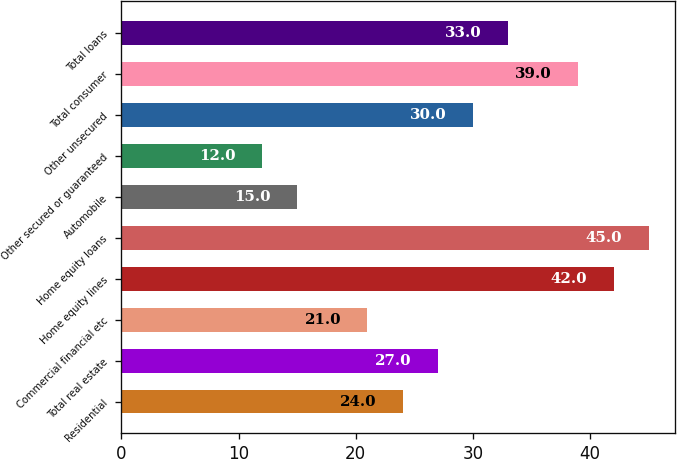Convert chart to OTSL. <chart><loc_0><loc_0><loc_500><loc_500><bar_chart><fcel>Residential<fcel>Total real estate<fcel>Commercial financial etc<fcel>Home equity lines<fcel>Home equity loans<fcel>Automobile<fcel>Other secured or guaranteed<fcel>Other unsecured<fcel>Total consumer<fcel>Total loans<nl><fcel>24<fcel>27<fcel>21<fcel>42<fcel>45<fcel>15<fcel>12<fcel>30<fcel>39<fcel>33<nl></chart> 